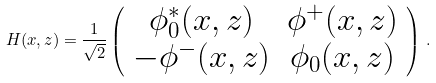<formula> <loc_0><loc_0><loc_500><loc_500>H ( x , z ) = \frac { 1 } { \sqrt { 2 } } \left ( \begin{array} { c c } \phi _ { 0 } ^ { * } ( x , z ) & \phi ^ { + } ( x , z ) \\ - \phi ^ { - } ( x , z ) & \phi _ { 0 } ( x , z ) \end{array} \right ) \, .</formula> 